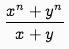Convert formula to latex. <formula><loc_0><loc_0><loc_500><loc_500>\frac { x ^ { n } + y ^ { n } } { x + y }</formula> 